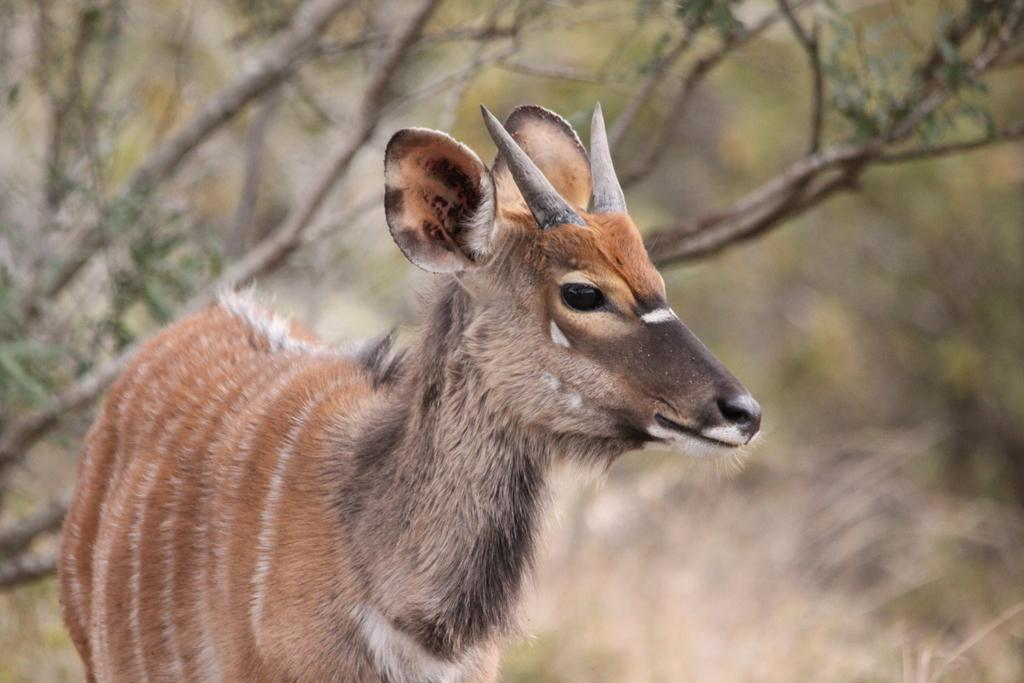What type of creature is present in the image? There is an animal in the image. Can you describe the color pattern of the animal? The animal has brown and white colors. What can be seen in the background of the image? There are trees in the background of the image. What is the color of the trees in the image? The trees are green in color. What type of food is the animal eating in the image? There is no food present in the image, and the animal is not shown eating anything. 